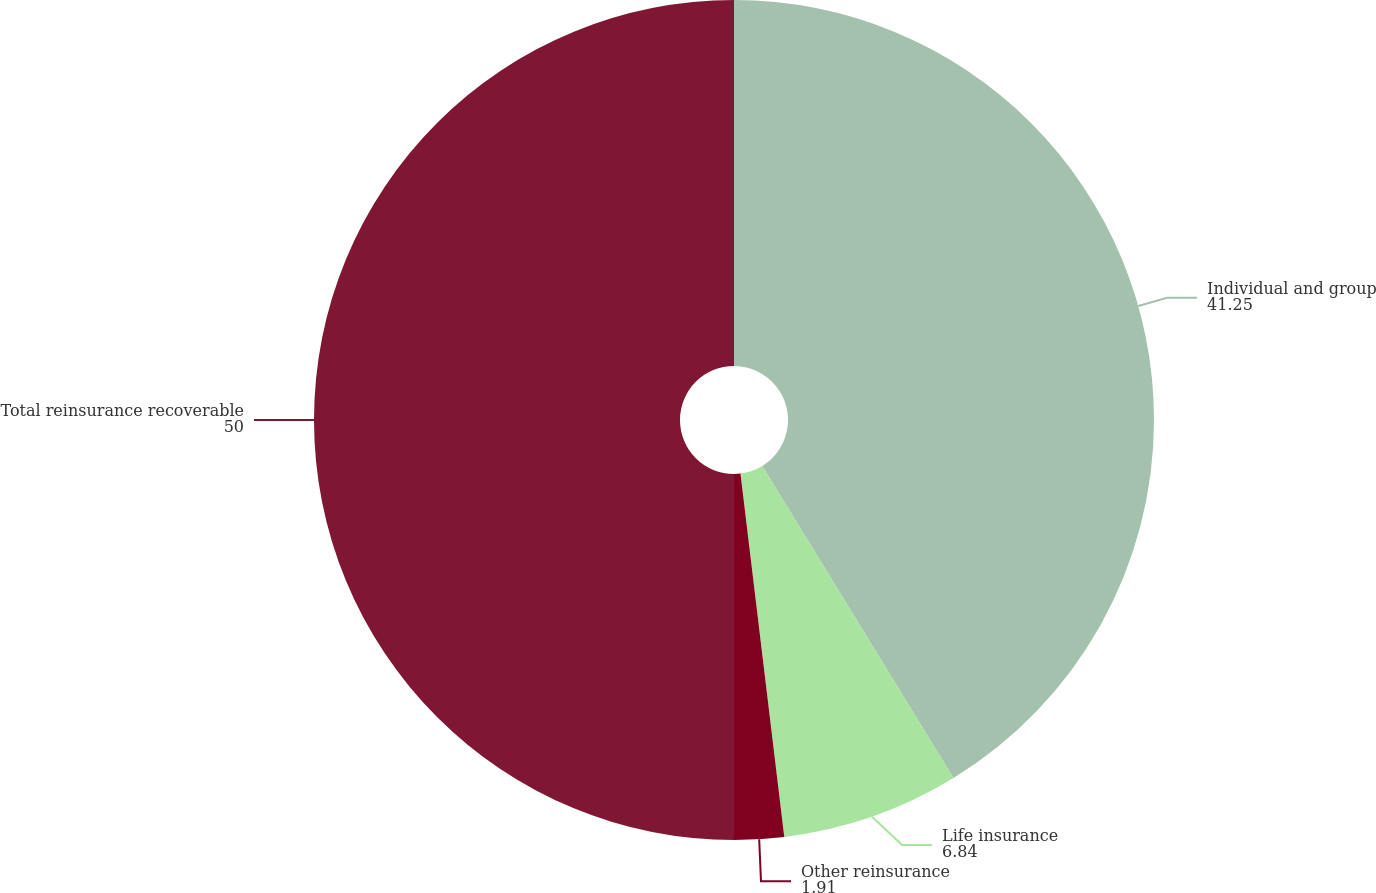Convert chart to OTSL. <chart><loc_0><loc_0><loc_500><loc_500><pie_chart><fcel>Individual and group<fcel>Life insurance<fcel>Other reinsurance<fcel>Total reinsurance recoverable<nl><fcel>41.25%<fcel>6.84%<fcel>1.91%<fcel>50.0%<nl></chart> 